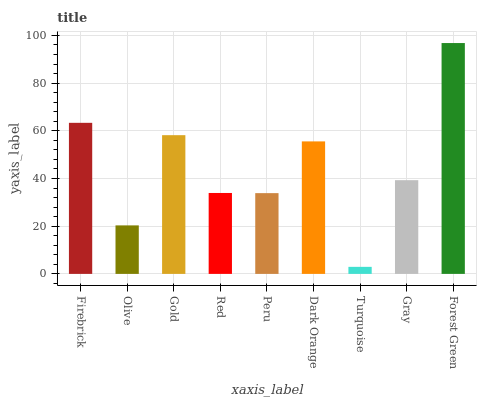Is Turquoise the minimum?
Answer yes or no. Yes. Is Forest Green the maximum?
Answer yes or no. Yes. Is Olive the minimum?
Answer yes or no. No. Is Olive the maximum?
Answer yes or no. No. Is Firebrick greater than Olive?
Answer yes or no. Yes. Is Olive less than Firebrick?
Answer yes or no. Yes. Is Olive greater than Firebrick?
Answer yes or no. No. Is Firebrick less than Olive?
Answer yes or no. No. Is Gray the high median?
Answer yes or no. Yes. Is Gray the low median?
Answer yes or no. Yes. Is Dark Orange the high median?
Answer yes or no. No. Is Dark Orange the low median?
Answer yes or no. No. 